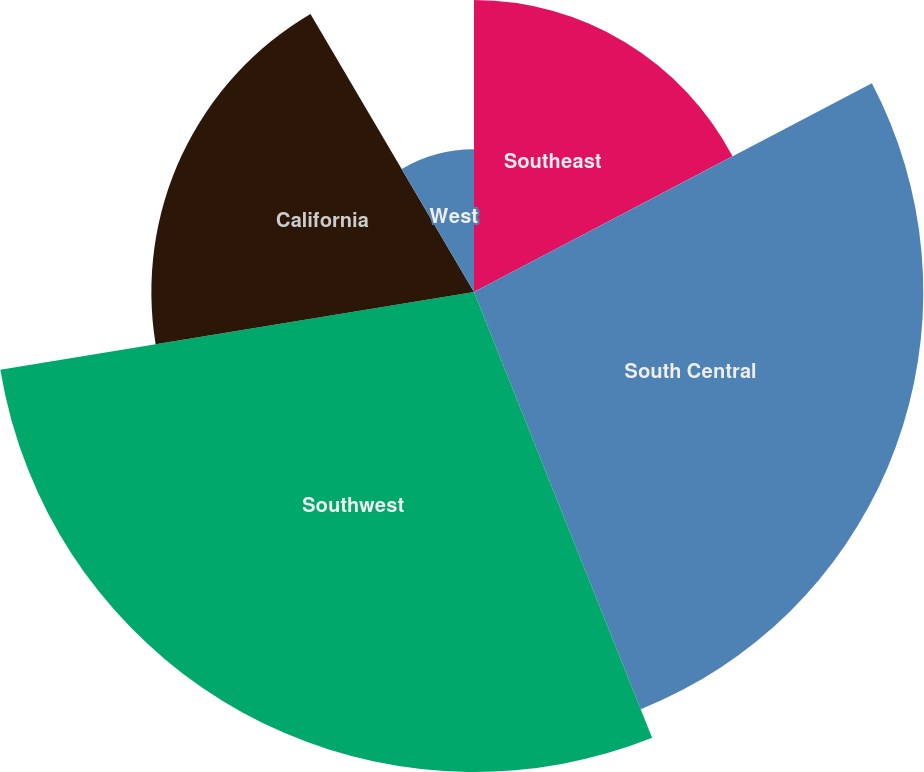Convert chart. <chart><loc_0><loc_0><loc_500><loc_500><pie_chart><fcel>Southeast<fcel>South Central<fcel>Southwest<fcel>California<fcel>West<nl><fcel>17.31%<fcel>26.64%<fcel>28.46%<fcel>19.13%<fcel>8.46%<nl></chart> 